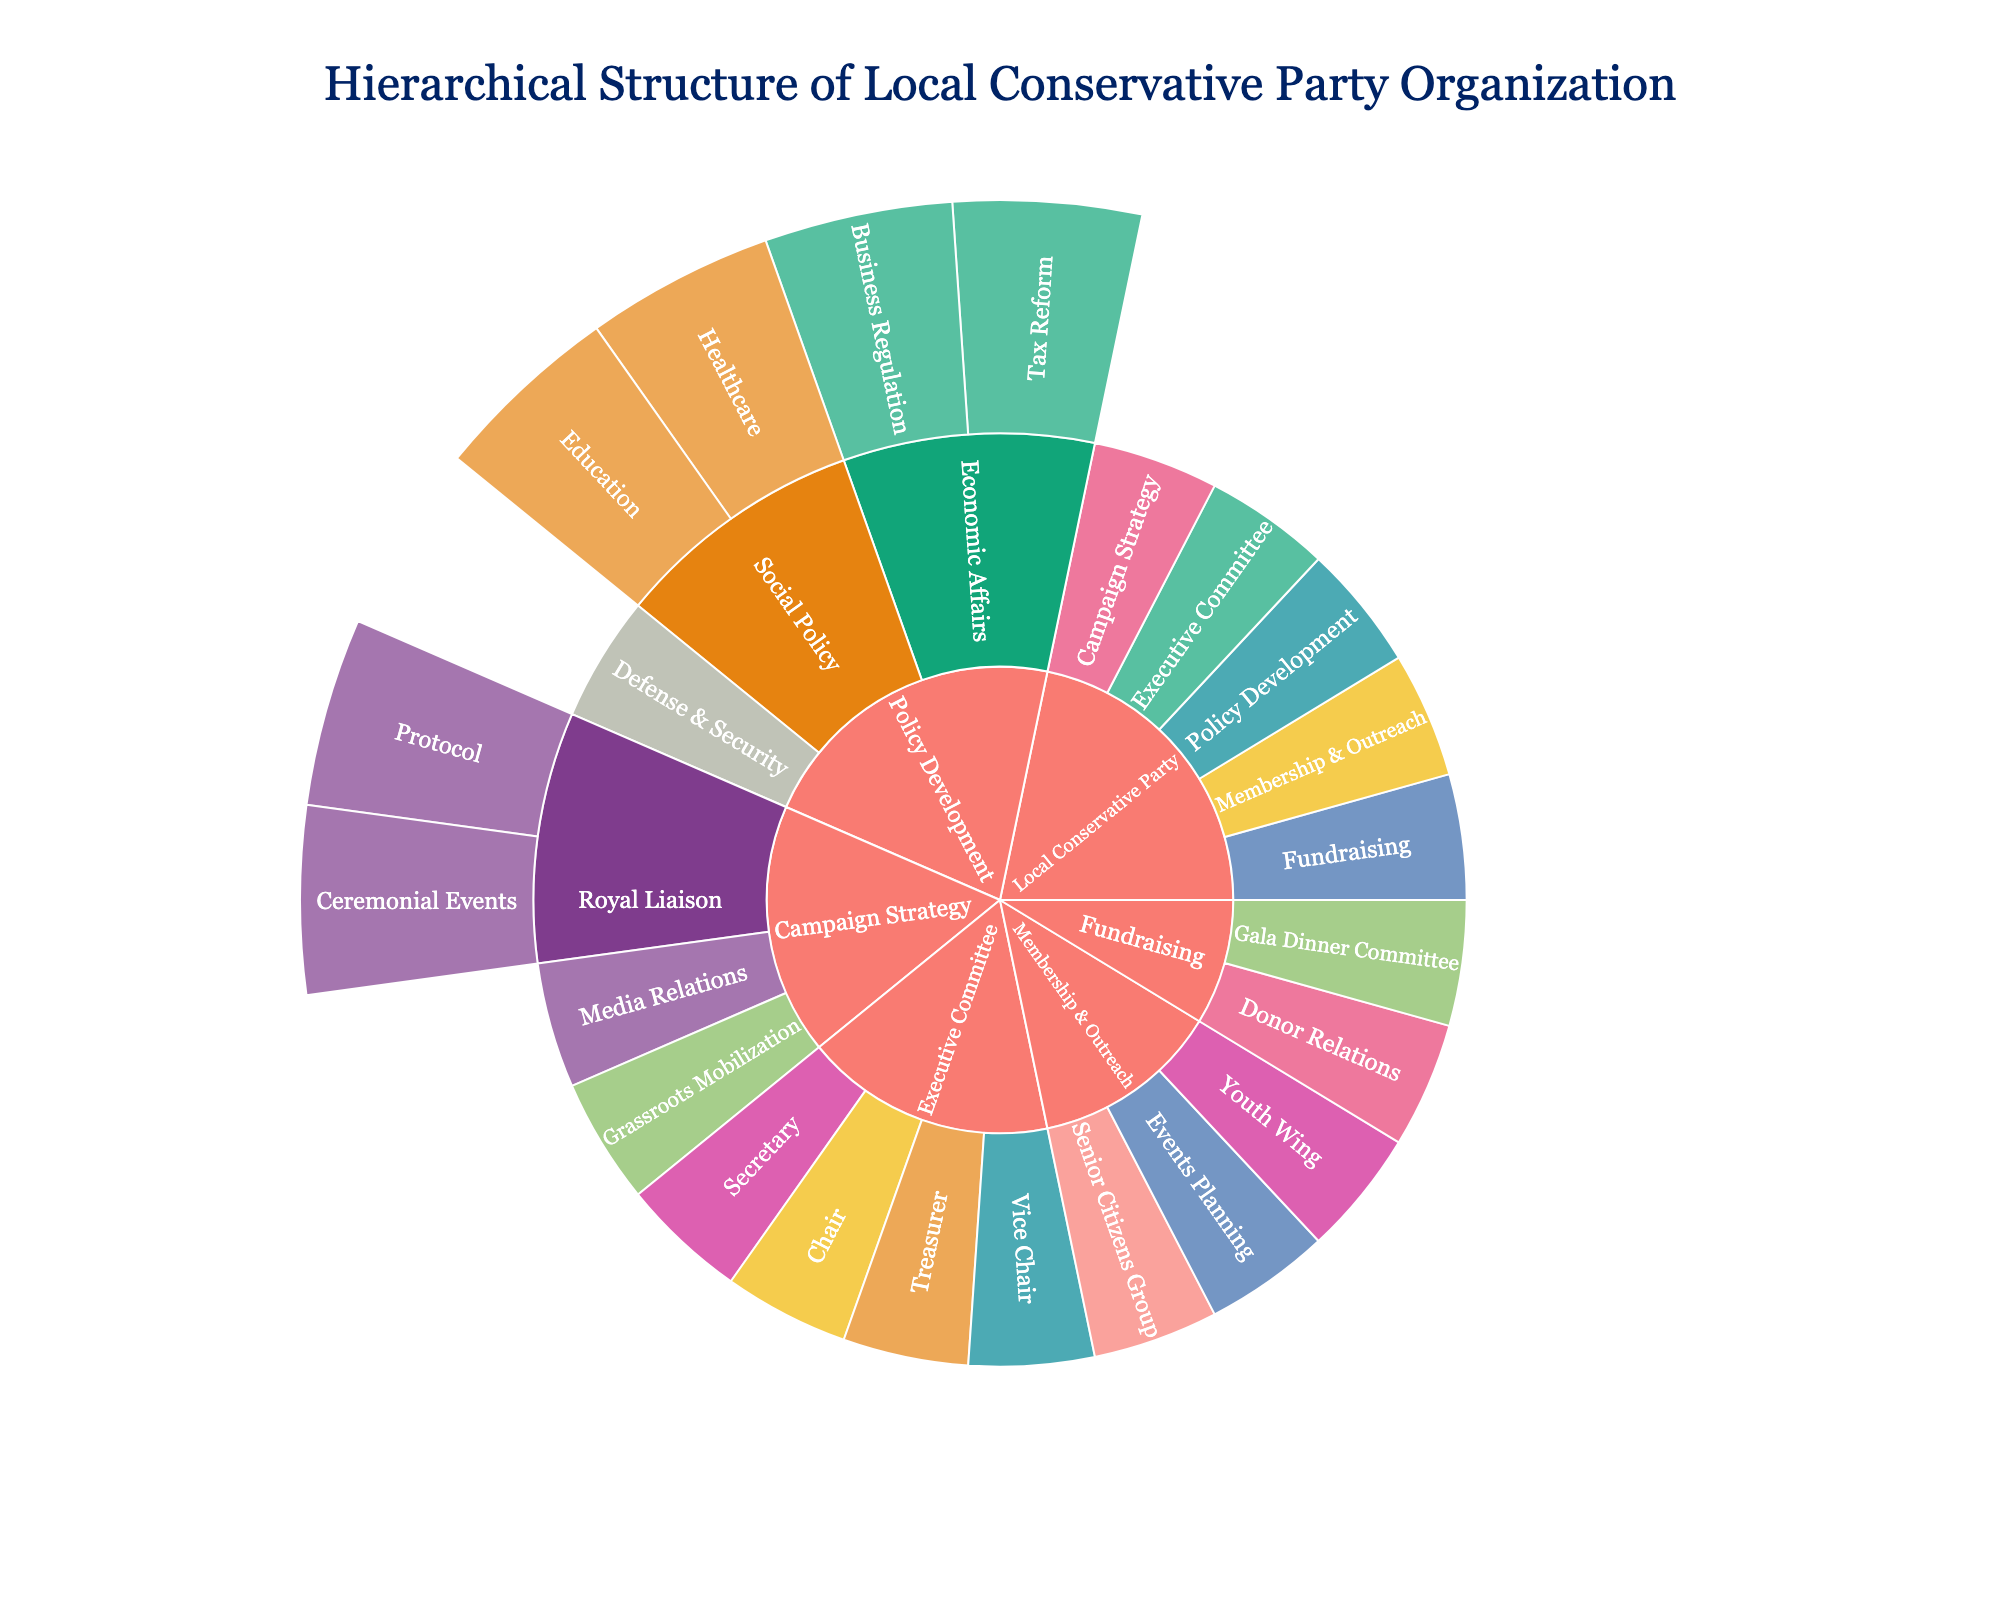What is the title of the plot? The title is displayed at the top of the figure. It’s centrally aligned and reads “Hierarchical Structure of Local Conservative Party Organization.”
Answer: Hierarchical Structure of Local Conservative Party Organization Which branch has the most sub-branches directly under it? Observe the central node and count the branches emanating from each main branch. The "Policy Development" branch has three sub-branches under it: Economic Affairs, Social Policy, and Defense & Security.
Answer: Policy Development What color is used for the Executive Committee branch? The colors are distinct for each branch. By looking at the sunburst plot, you can see the color associated with "Executive Committee". It uses a specific color from the plot's palette.
Answer: Blue How many levels can be visualized in this sunburst plot? The plot has concentric layers. Start from the center (level 0) and count outwards until the last visible layer, including empty levels. There are root (Local Conservative Party), branch, sub-branch, and committee levels.
Answer: 4 Which committees fall under Economic Affairs? Navigate from Policy Development -> Economic Affairs and then check the hierarchy's branches. It has "Tax Reform" and "Business Regulation" committees.
Answer: Tax Reform, Business Regulation Is there a branch that has no sub-branches or committees under it? Check each branch for subdivisions or committees. The "Defense & Security" branch under "Policy Development" has no further branches or committees under it.
Answer: Defense & Security Which is larger in the plot: Membership & Outreach or Fundraising branch? Compare the arc lengths of both branches. "Membership & Outreach" has three sub-branches and "Fundraising" has two. The arc length for "Membership & Outreach" is longer.
Answer: Membership & Outreach Which committee under the Campaign Strategy branch deals with royal matters? Follow the hierarchy under Campaign Strategy and identify committees linked with terms related to the monarchy/royalty. "Royal Liaison" under Campaign Strategy deals with "Protocol" and "Ceremonial Events".
Answer: Royal Liaison What is the most distinguishing feature of a sunburst plot compared to other chart types? Sunburst plots are unique because they represent hierarchical data with concentric circles, where each level of the hierarchy is displayed in a ring and can show the relationships between levels more intuitively than other types of plots.
Answer: Hierarchical rings 